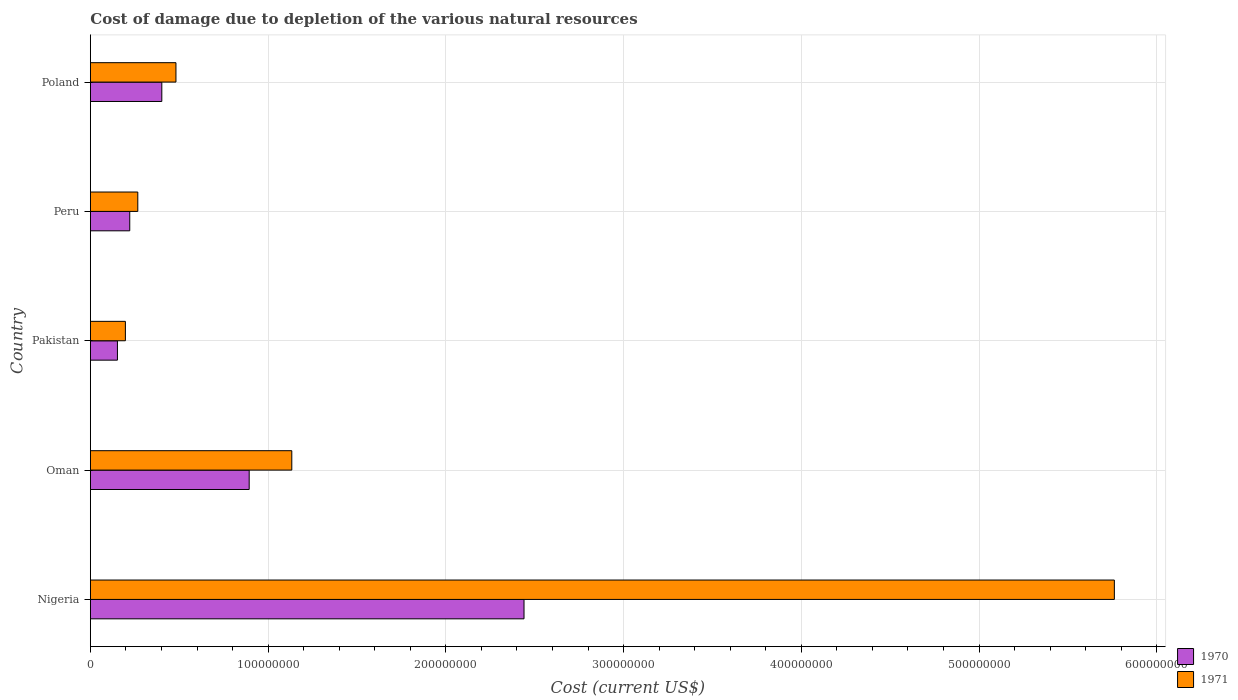How many different coloured bars are there?
Keep it short and to the point. 2. How many groups of bars are there?
Offer a terse response. 5. How many bars are there on the 1st tick from the top?
Provide a short and direct response. 2. What is the cost of damage caused due to the depletion of various natural resources in 1971 in Nigeria?
Provide a succinct answer. 5.76e+08. Across all countries, what is the maximum cost of damage caused due to the depletion of various natural resources in 1970?
Your response must be concise. 2.44e+08. Across all countries, what is the minimum cost of damage caused due to the depletion of various natural resources in 1970?
Give a very brief answer. 1.52e+07. In which country was the cost of damage caused due to the depletion of various natural resources in 1971 maximum?
Offer a very short reply. Nigeria. In which country was the cost of damage caused due to the depletion of various natural resources in 1970 minimum?
Ensure brevity in your answer.  Pakistan. What is the total cost of damage caused due to the depletion of various natural resources in 1971 in the graph?
Your answer should be very brief. 7.84e+08. What is the difference between the cost of damage caused due to the depletion of various natural resources in 1970 in Oman and that in Poland?
Your response must be concise. 4.92e+07. What is the difference between the cost of damage caused due to the depletion of various natural resources in 1971 in Nigeria and the cost of damage caused due to the depletion of various natural resources in 1970 in Pakistan?
Keep it short and to the point. 5.61e+08. What is the average cost of damage caused due to the depletion of various natural resources in 1971 per country?
Provide a short and direct response. 1.57e+08. What is the difference between the cost of damage caused due to the depletion of various natural resources in 1970 and cost of damage caused due to the depletion of various natural resources in 1971 in Nigeria?
Your answer should be very brief. -3.32e+08. What is the ratio of the cost of damage caused due to the depletion of various natural resources in 1970 in Oman to that in Pakistan?
Ensure brevity in your answer.  5.87. What is the difference between the highest and the second highest cost of damage caused due to the depletion of various natural resources in 1970?
Offer a very short reply. 1.55e+08. What is the difference between the highest and the lowest cost of damage caused due to the depletion of various natural resources in 1971?
Make the answer very short. 5.56e+08. What does the 1st bar from the top in Oman represents?
Your answer should be very brief. 1971. What does the 1st bar from the bottom in Oman represents?
Your response must be concise. 1970. How many bars are there?
Give a very brief answer. 10. Are all the bars in the graph horizontal?
Provide a succinct answer. Yes. How many countries are there in the graph?
Your answer should be very brief. 5. Are the values on the major ticks of X-axis written in scientific E-notation?
Your response must be concise. No. How many legend labels are there?
Give a very brief answer. 2. What is the title of the graph?
Your answer should be very brief. Cost of damage due to depletion of the various natural resources. What is the label or title of the X-axis?
Provide a short and direct response. Cost (current US$). What is the label or title of the Y-axis?
Offer a very short reply. Country. What is the Cost (current US$) in 1970 in Nigeria?
Ensure brevity in your answer.  2.44e+08. What is the Cost (current US$) of 1971 in Nigeria?
Provide a succinct answer. 5.76e+08. What is the Cost (current US$) in 1970 in Oman?
Make the answer very short. 8.94e+07. What is the Cost (current US$) of 1971 in Oman?
Provide a succinct answer. 1.13e+08. What is the Cost (current US$) in 1970 in Pakistan?
Keep it short and to the point. 1.52e+07. What is the Cost (current US$) in 1971 in Pakistan?
Offer a terse response. 1.97e+07. What is the Cost (current US$) of 1970 in Peru?
Provide a short and direct response. 2.22e+07. What is the Cost (current US$) of 1971 in Peru?
Offer a very short reply. 2.67e+07. What is the Cost (current US$) in 1970 in Poland?
Offer a terse response. 4.02e+07. What is the Cost (current US$) of 1971 in Poland?
Ensure brevity in your answer.  4.82e+07. Across all countries, what is the maximum Cost (current US$) of 1970?
Offer a very short reply. 2.44e+08. Across all countries, what is the maximum Cost (current US$) of 1971?
Offer a very short reply. 5.76e+08. Across all countries, what is the minimum Cost (current US$) of 1970?
Your answer should be very brief. 1.52e+07. Across all countries, what is the minimum Cost (current US$) in 1971?
Give a very brief answer. 1.97e+07. What is the total Cost (current US$) in 1970 in the graph?
Offer a very short reply. 4.11e+08. What is the total Cost (current US$) in 1971 in the graph?
Provide a succinct answer. 7.84e+08. What is the difference between the Cost (current US$) of 1970 in Nigeria and that in Oman?
Keep it short and to the point. 1.55e+08. What is the difference between the Cost (current US$) of 1971 in Nigeria and that in Oman?
Offer a very short reply. 4.63e+08. What is the difference between the Cost (current US$) of 1970 in Nigeria and that in Pakistan?
Keep it short and to the point. 2.29e+08. What is the difference between the Cost (current US$) of 1971 in Nigeria and that in Pakistan?
Give a very brief answer. 5.56e+08. What is the difference between the Cost (current US$) of 1970 in Nigeria and that in Peru?
Your answer should be compact. 2.22e+08. What is the difference between the Cost (current US$) in 1971 in Nigeria and that in Peru?
Provide a succinct answer. 5.49e+08. What is the difference between the Cost (current US$) in 1970 in Nigeria and that in Poland?
Provide a short and direct response. 2.04e+08. What is the difference between the Cost (current US$) in 1971 in Nigeria and that in Poland?
Give a very brief answer. 5.28e+08. What is the difference between the Cost (current US$) of 1970 in Oman and that in Pakistan?
Your answer should be very brief. 7.41e+07. What is the difference between the Cost (current US$) in 1971 in Oman and that in Pakistan?
Your answer should be very brief. 9.36e+07. What is the difference between the Cost (current US$) of 1970 in Oman and that in Peru?
Offer a very short reply. 6.72e+07. What is the difference between the Cost (current US$) in 1971 in Oman and that in Peru?
Offer a terse response. 8.66e+07. What is the difference between the Cost (current US$) in 1970 in Oman and that in Poland?
Offer a terse response. 4.92e+07. What is the difference between the Cost (current US$) in 1971 in Oman and that in Poland?
Your response must be concise. 6.52e+07. What is the difference between the Cost (current US$) in 1970 in Pakistan and that in Peru?
Provide a short and direct response. -6.92e+06. What is the difference between the Cost (current US$) of 1971 in Pakistan and that in Peru?
Give a very brief answer. -6.98e+06. What is the difference between the Cost (current US$) of 1970 in Pakistan and that in Poland?
Give a very brief answer. -2.50e+07. What is the difference between the Cost (current US$) in 1971 in Pakistan and that in Poland?
Offer a very short reply. -2.84e+07. What is the difference between the Cost (current US$) in 1970 in Peru and that in Poland?
Your response must be concise. -1.80e+07. What is the difference between the Cost (current US$) in 1971 in Peru and that in Poland?
Your answer should be very brief. -2.15e+07. What is the difference between the Cost (current US$) in 1970 in Nigeria and the Cost (current US$) in 1971 in Oman?
Offer a very short reply. 1.31e+08. What is the difference between the Cost (current US$) of 1970 in Nigeria and the Cost (current US$) of 1971 in Pakistan?
Offer a very short reply. 2.24e+08. What is the difference between the Cost (current US$) of 1970 in Nigeria and the Cost (current US$) of 1971 in Peru?
Provide a short and direct response. 2.17e+08. What is the difference between the Cost (current US$) of 1970 in Nigeria and the Cost (current US$) of 1971 in Poland?
Make the answer very short. 1.96e+08. What is the difference between the Cost (current US$) in 1970 in Oman and the Cost (current US$) in 1971 in Pakistan?
Keep it short and to the point. 6.96e+07. What is the difference between the Cost (current US$) of 1970 in Oman and the Cost (current US$) of 1971 in Peru?
Your response must be concise. 6.27e+07. What is the difference between the Cost (current US$) of 1970 in Oman and the Cost (current US$) of 1971 in Poland?
Your response must be concise. 4.12e+07. What is the difference between the Cost (current US$) of 1970 in Pakistan and the Cost (current US$) of 1971 in Peru?
Provide a short and direct response. -1.15e+07. What is the difference between the Cost (current US$) in 1970 in Pakistan and the Cost (current US$) in 1971 in Poland?
Your answer should be very brief. -3.29e+07. What is the difference between the Cost (current US$) of 1970 in Peru and the Cost (current US$) of 1971 in Poland?
Provide a short and direct response. -2.60e+07. What is the average Cost (current US$) of 1970 per country?
Keep it short and to the point. 8.22e+07. What is the average Cost (current US$) in 1971 per country?
Offer a terse response. 1.57e+08. What is the difference between the Cost (current US$) of 1970 and Cost (current US$) of 1971 in Nigeria?
Provide a short and direct response. -3.32e+08. What is the difference between the Cost (current US$) in 1970 and Cost (current US$) in 1971 in Oman?
Your answer should be very brief. -2.40e+07. What is the difference between the Cost (current US$) of 1970 and Cost (current US$) of 1971 in Pakistan?
Keep it short and to the point. -4.48e+06. What is the difference between the Cost (current US$) in 1970 and Cost (current US$) in 1971 in Peru?
Your answer should be compact. -4.53e+06. What is the difference between the Cost (current US$) in 1970 and Cost (current US$) in 1971 in Poland?
Ensure brevity in your answer.  -7.95e+06. What is the ratio of the Cost (current US$) of 1970 in Nigeria to that in Oman?
Provide a short and direct response. 2.73. What is the ratio of the Cost (current US$) of 1971 in Nigeria to that in Oman?
Offer a terse response. 5.08. What is the ratio of the Cost (current US$) of 1970 in Nigeria to that in Pakistan?
Give a very brief answer. 16.02. What is the ratio of the Cost (current US$) of 1971 in Nigeria to that in Pakistan?
Keep it short and to the point. 29.23. What is the ratio of the Cost (current US$) of 1970 in Nigeria to that in Peru?
Your response must be concise. 11.01. What is the ratio of the Cost (current US$) of 1971 in Nigeria to that in Peru?
Your answer should be compact. 21.59. What is the ratio of the Cost (current US$) of 1970 in Nigeria to that in Poland?
Offer a terse response. 6.07. What is the ratio of the Cost (current US$) of 1971 in Nigeria to that in Poland?
Offer a terse response. 11.96. What is the ratio of the Cost (current US$) of 1970 in Oman to that in Pakistan?
Ensure brevity in your answer.  5.87. What is the ratio of the Cost (current US$) of 1971 in Oman to that in Pakistan?
Keep it short and to the point. 5.75. What is the ratio of the Cost (current US$) in 1970 in Oman to that in Peru?
Ensure brevity in your answer.  4.03. What is the ratio of the Cost (current US$) of 1971 in Oman to that in Peru?
Your response must be concise. 4.25. What is the ratio of the Cost (current US$) of 1970 in Oman to that in Poland?
Offer a very short reply. 2.22. What is the ratio of the Cost (current US$) in 1971 in Oman to that in Poland?
Offer a very short reply. 2.35. What is the ratio of the Cost (current US$) of 1970 in Pakistan to that in Peru?
Keep it short and to the point. 0.69. What is the ratio of the Cost (current US$) in 1971 in Pakistan to that in Peru?
Your response must be concise. 0.74. What is the ratio of the Cost (current US$) of 1970 in Pakistan to that in Poland?
Provide a short and direct response. 0.38. What is the ratio of the Cost (current US$) in 1971 in Pakistan to that in Poland?
Your answer should be compact. 0.41. What is the ratio of the Cost (current US$) in 1970 in Peru to that in Poland?
Your answer should be compact. 0.55. What is the ratio of the Cost (current US$) in 1971 in Peru to that in Poland?
Give a very brief answer. 0.55. What is the difference between the highest and the second highest Cost (current US$) of 1970?
Give a very brief answer. 1.55e+08. What is the difference between the highest and the second highest Cost (current US$) in 1971?
Offer a very short reply. 4.63e+08. What is the difference between the highest and the lowest Cost (current US$) in 1970?
Keep it short and to the point. 2.29e+08. What is the difference between the highest and the lowest Cost (current US$) in 1971?
Keep it short and to the point. 5.56e+08. 